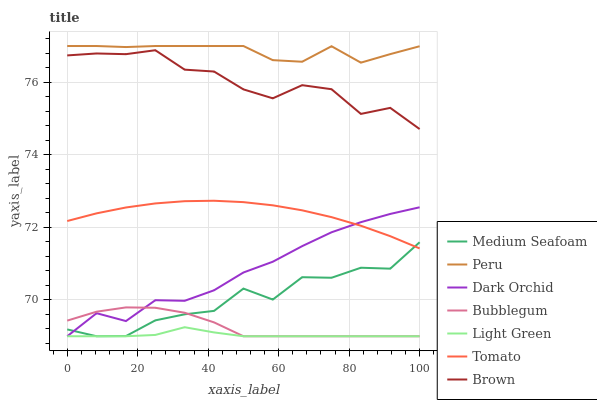Does Light Green have the minimum area under the curve?
Answer yes or no. Yes. Does Peru have the maximum area under the curve?
Answer yes or no. Yes. Does Brown have the minimum area under the curve?
Answer yes or no. No. Does Brown have the maximum area under the curve?
Answer yes or no. No. Is Tomato the smoothest?
Answer yes or no. Yes. Is Medium Seafoam the roughest?
Answer yes or no. Yes. Is Brown the smoothest?
Answer yes or no. No. Is Brown the roughest?
Answer yes or no. No. Does Dark Orchid have the lowest value?
Answer yes or no. Yes. Does Brown have the lowest value?
Answer yes or no. No. Does Peru have the highest value?
Answer yes or no. Yes. Does Brown have the highest value?
Answer yes or no. No. Is Dark Orchid less than Brown?
Answer yes or no. Yes. Is Peru greater than Tomato?
Answer yes or no. Yes. Does Medium Seafoam intersect Light Green?
Answer yes or no. Yes. Is Medium Seafoam less than Light Green?
Answer yes or no. No. Is Medium Seafoam greater than Light Green?
Answer yes or no. No. Does Dark Orchid intersect Brown?
Answer yes or no. No. 